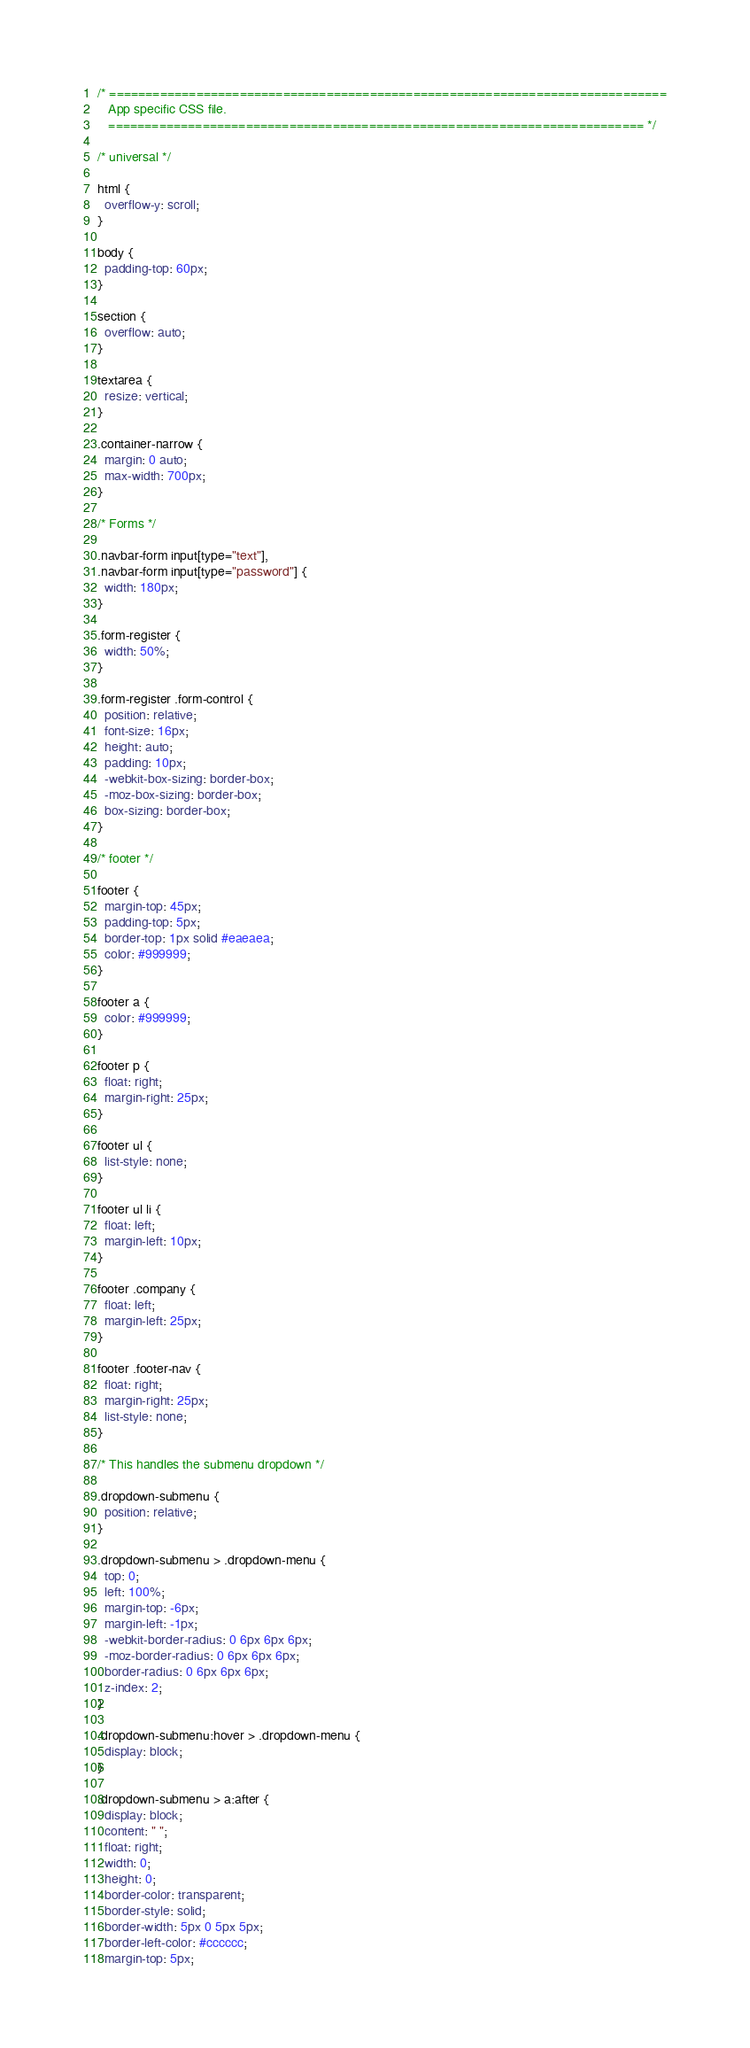<code> <loc_0><loc_0><loc_500><loc_500><_CSS_>/* =============================================================================
   App specific CSS file.
   ========================================================================== */

/* universal */

html {
  overflow-y: scroll;
}

body {
  padding-top: 60px;
}

section {
  overflow: auto;
}

textarea {
  resize: vertical;
}

.container-narrow {
  margin: 0 auto;
  max-width: 700px;
}

/* Forms */

.navbar-form input[type="text"],
.navbar-form input[type="password"] {
  width: 180px;
}

.form-register {
  width: 50%;
}

.form-register .form-control {
  position: relative;
  font-size: 16px;
  height: auto;
  padding: 10px;
  -webkit-box-sizing: border-box;
  -moz-box-sizing: border-box;
  box-sizing: border-box;
}

/* footer */

footer {
  margin-top: 45px;
  padding-top: 5px;
  border-top: 1px solid #eaeaea;
  color: #999999;
}

footer a {
  color: #999999;
}

footer p {
  float: right;
  margin-right: 25px;
}

footer ul {
  list-style: none;
}

footer ul li {
  float: left;
  margin-left: 10px;
}

footer .company {
  float: left;
  margin-left: 25px;
}

footer .footer-nav {
  float: right;
  margin-right: 25px;
  list-style: none;
}

/* This handles the submenu dropdown */

.dropdown-submenu {
  position: relative;
}

.dropdown-submenu > .dropdown-menu {
  top: 0;
  left: 100%;
  margin-top: -6px;
  margin-left: -1px;
  -webkit-border-radius: 0 6px 6px 6px;
  -moz-border-radius: 0 6px 6px 6px;
  border-radius: 0 6px 6px 6px;
  z-index: 2;
}

.dropdown-submenu:hover > .dropdown-menu {
  display: block;
}

.dropdown-submenu > a:after {
  display: block;
  content: " ";
  float: right;
  width: 0;
  height: 0;
  border-color: transparent;
  border-style: solid;
  border-width: 5px 0 5px 5px;
  border-left-color: #cccccc;
  margin-top: 5px;</code> 